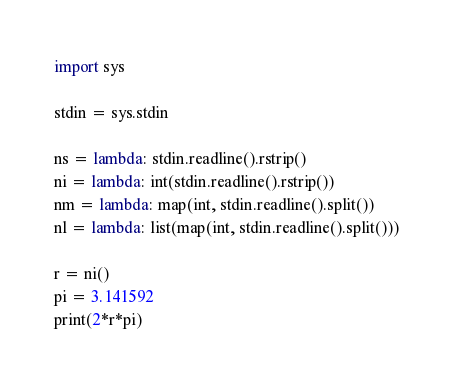Convert code to text. <code><loc_0><loc_0><loc_500><loc_500><_Python_>import sys

stdin = sys.stdin

ns = lambda: stdin.readline().rstrip()
ni = lambda: int(stdin.readline().rstrip())
nm = lambda: map(int, stdin.readline().split())
nl = lambda: list(map(int, stdin.readline().split()))

r = ni()
pi = 3.141592
print(2*r*pi)
</code> 